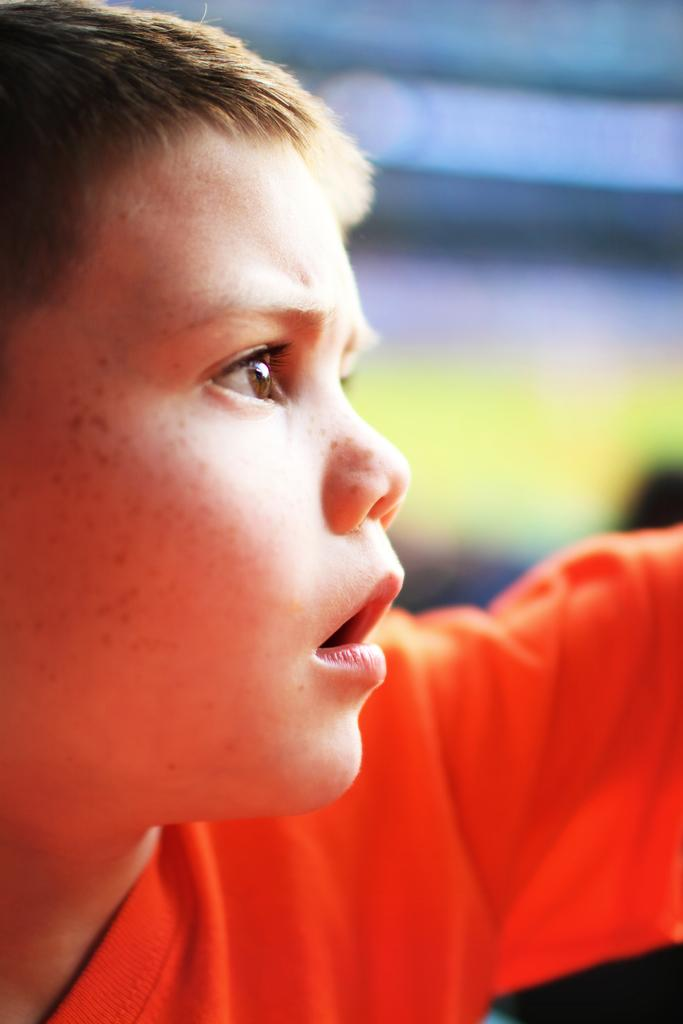What is the main subject of the image? There is a boy in the image. Can you describe the background of the image? The background of the image is blurred. How many rabbits can be seen in the image? There are no rabbits present in the image. What type of knowledge is the boy demonstrating in the image? The image does not show the boy demonstrating any specific knowledge. 